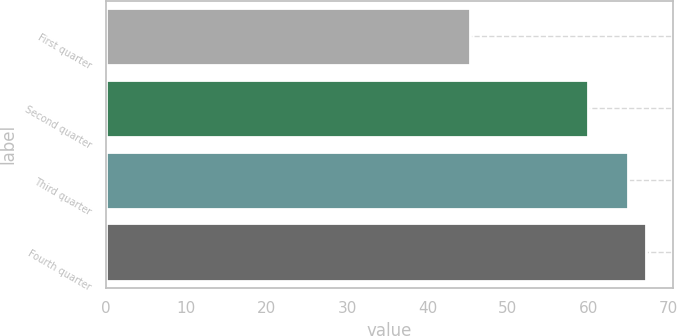Convert chart. <chart><loc_0><loc_0><loc_500><loc_500><bar_chart><fcel>First quarter<fcel>Second quarter<fcel>Third quarter<fcel>Fourth quarter<nl><fcel>45.27<fcel>59.95<fcel>64.98<fcel>67.15<nl></chart> 